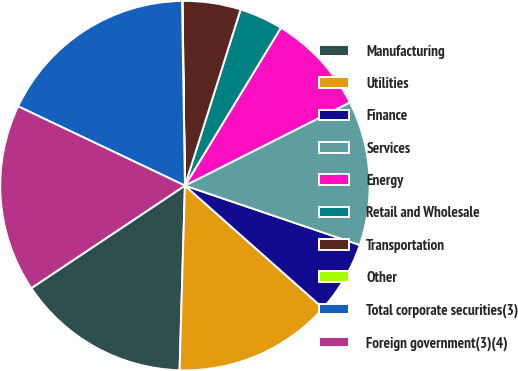Convert chart. <chart><loc_0><loc_0><loc_500><loc_500><pie_chart><fcel>Manufacturing<fcel>Utilities<fcel>Finance<fcel>Services<fcel>Energy<fcel>Retail and Wholesale<fcel>Transportation<fcel>Other<fcel>Total corporate securities(3)<fcel>Foreign government(3)(4)<nl><fcel>15.17%<fcel>13.91%<fcel>6.34%<fcel>12.65%<fcel>8.87%<fcel>3.82%<fcel>5.08%<fcel>0.04%<fcel>17.69%<fcel>16.43%<nl></chart> 